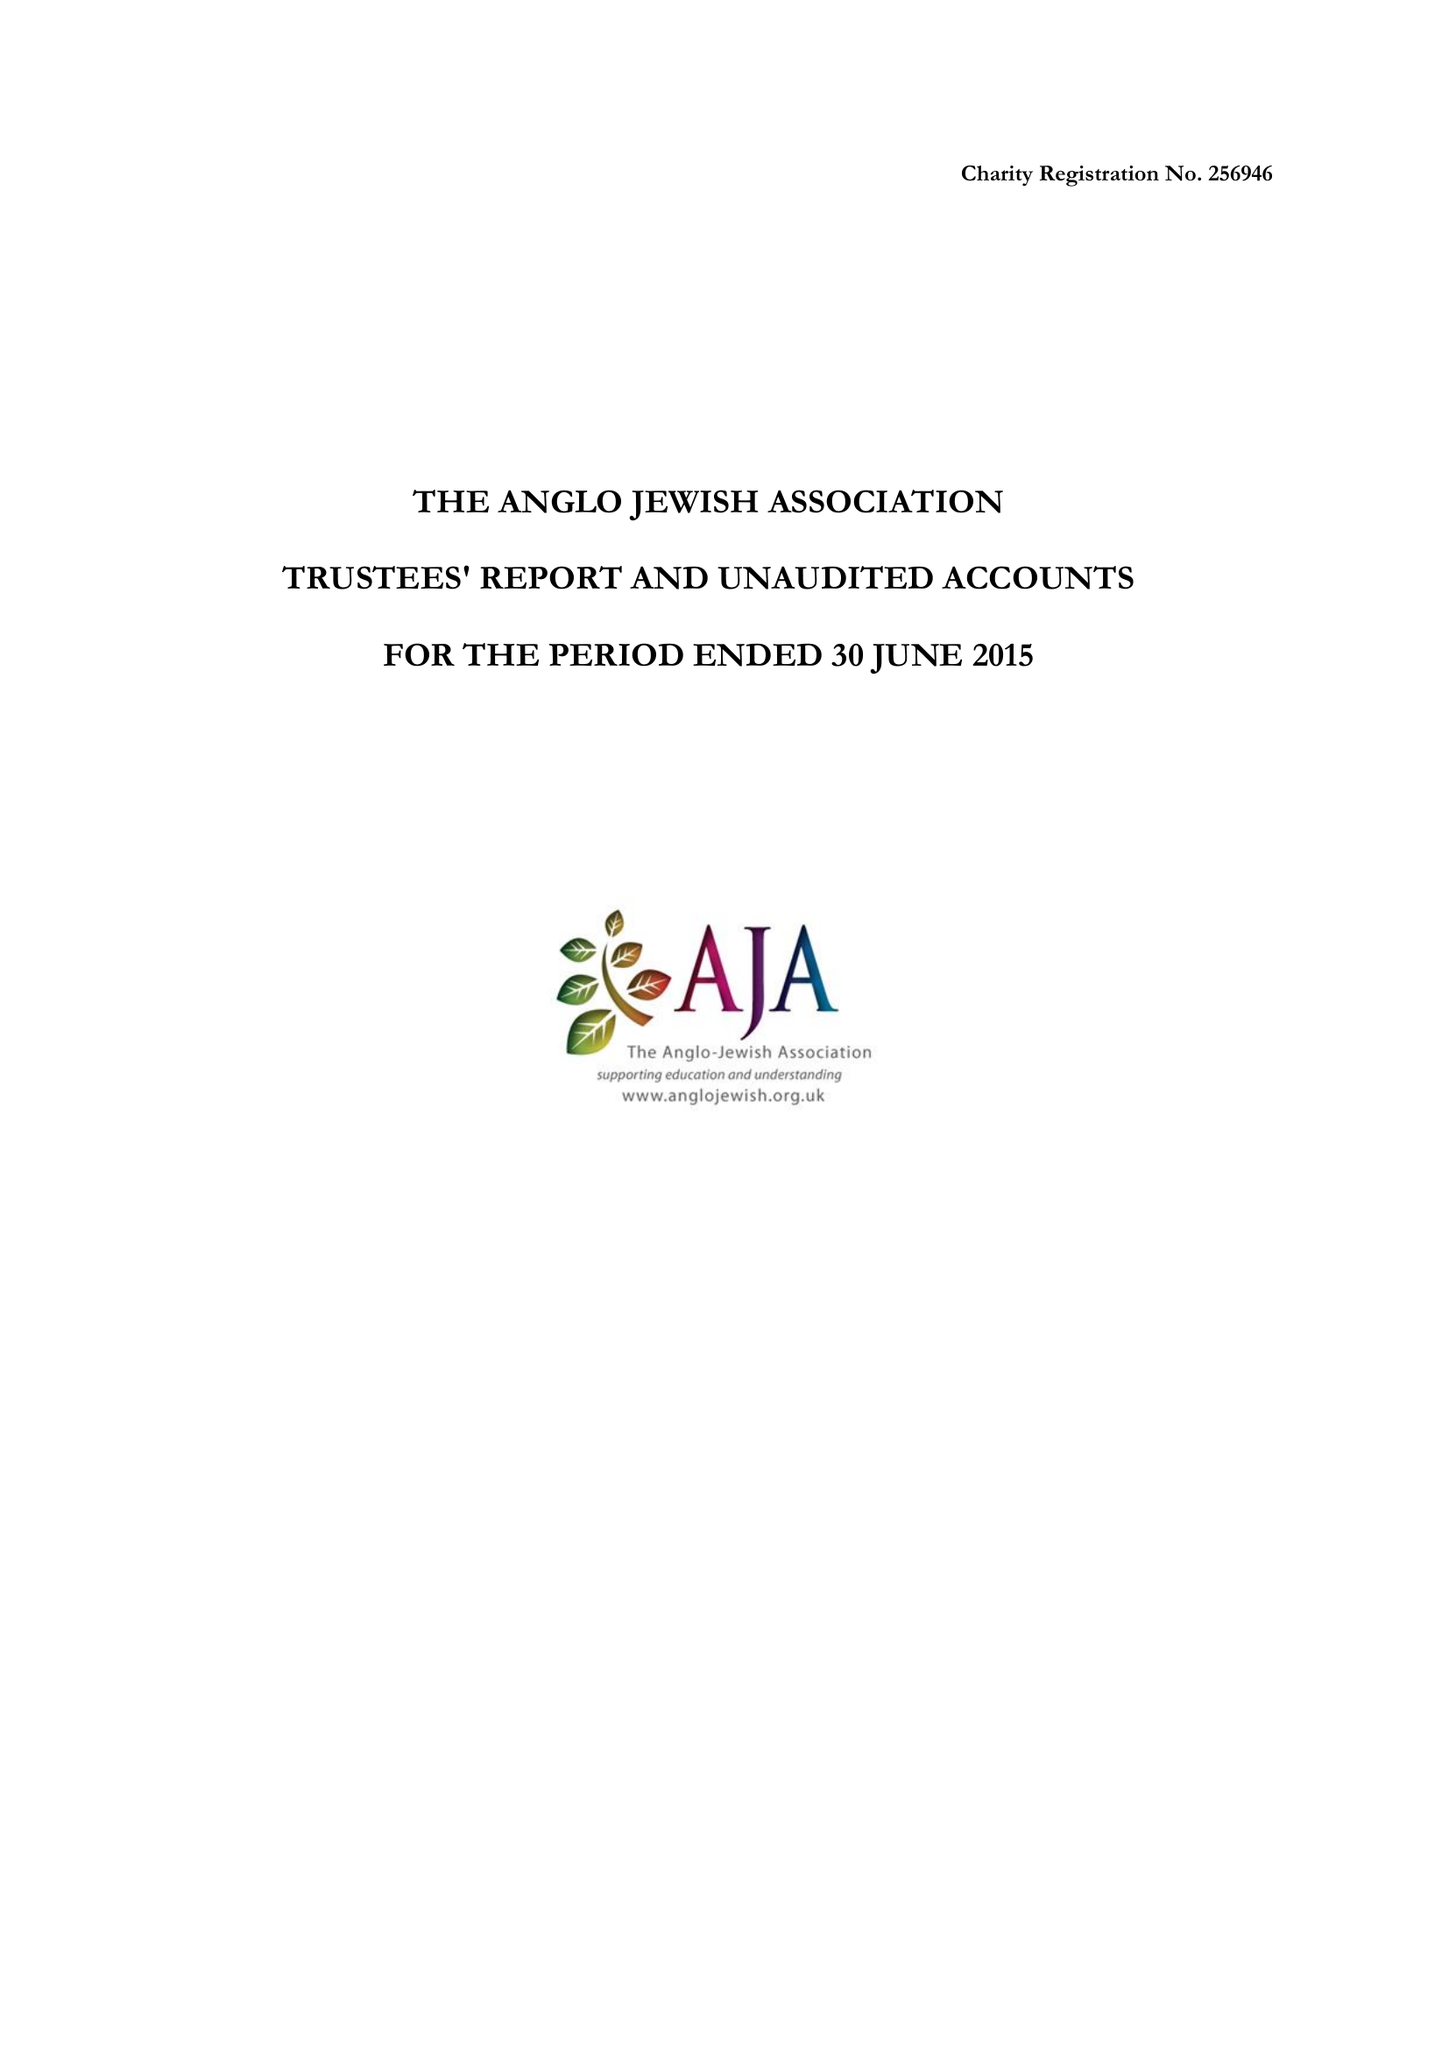What is the value for the income_annually_in_british_pounds?
Answer the question using a single word or phrase. 83177.00 